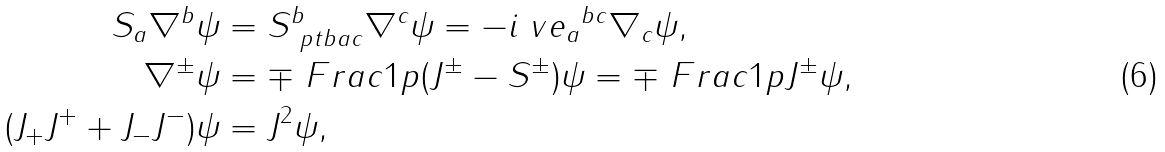Convert formula to latex. <formula><loc_0><loc_0><loc_500><loc_500>S _ { a } \nabla ^ { b } \psi & = S ^ { b } _ { \ p t { b } a c } \nabla ^ { c } \psi = - i { \ v e _ { a } } ^ { b c } \nabla _ { c } \psi , \\ \nabla ^ { \pm } \psi & = \mp \ F r a c { 1 } { p } ( J ^ { \pm } - S ^ { \pm } ) \psi = \mp \ F r a c { 1 } { p } J ^ { \pm } \psi , \\ ( J _ { + } J ^ { + } + J _ { - } J ^ { - } ) \psi & = J ^ { 2 } \psi ,</formula> 